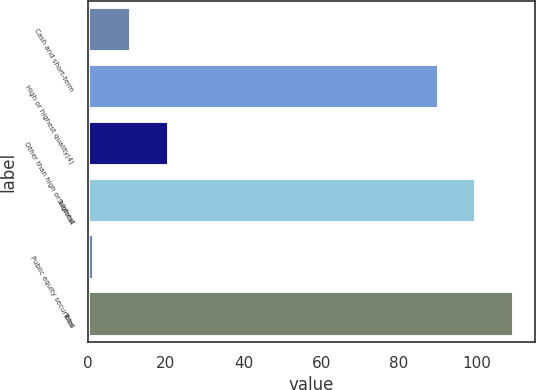Convert chart to OTSL. <chart><loc_0><loc_0><loc_500><loc_500><bar_chart><fcel>Cash and short-term<fcel>High or highest quality(4)<fcel>Other than high or highest<fcel>Subtotal<fcel>Public equity securities<fcel>Total<nl><fcel>11.2<fcel>90.2<fcel>20.8<fcel>99.8<fcel>1.6<fcel>109.4<nl></chart> 